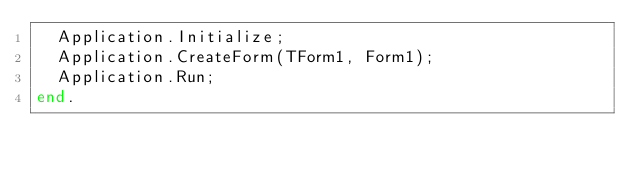Convert code to text. <code><loc_0><loc_0><loc_500><loc_500><_Pascal_>  Application.Initialize;
  Application.CreateForm(TForm1, Form1);
  Application.Run;
end.

</code> 